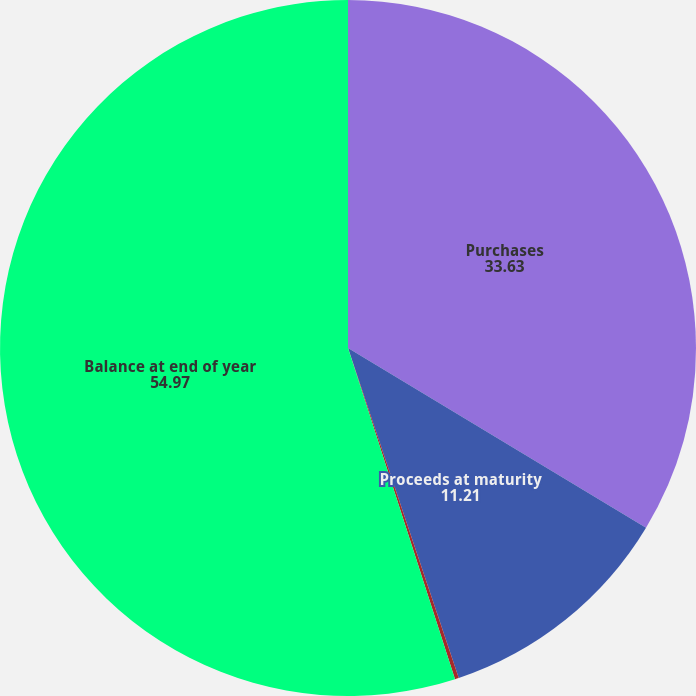<chart> <loc_0><loc_0><loc_500><loc_500><pie_chart><fcel>Purchases<fcel>Proceeds at maturity<fcel>Unrealized gains (losses)<fcel>Balance at end of year<nl><fcel>33.63%<fcel>11.21%<fcel>0.18%<fcel>54.97%<nl></chart> 